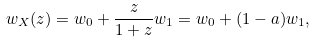Convert formula to latex. <formula><loc_0><loc_0><loc_500><loc_500>w _ { X } ( z ) = w _ { 0 } + \frac { z } { 1 + z } w _ { 1 } = w _ { 0 } + ( 1 - a ) w _ { 1 } ,</formula> 